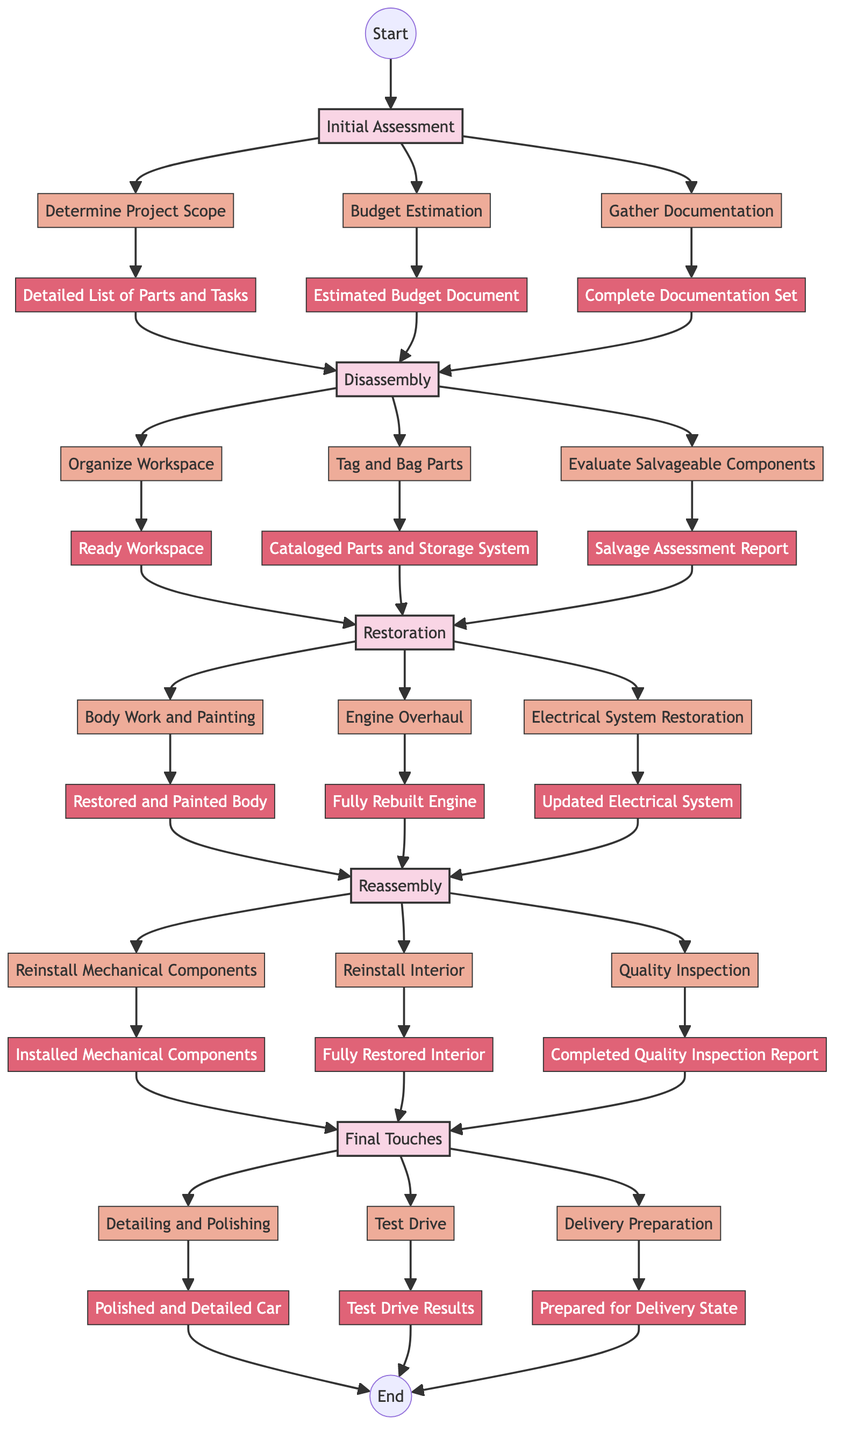What is the first phase in the restoration process? The diagram indicates that the first phase is labeled "Initial Assessment." This is the starting point of the flowchart, leading to steps involved in assessing the vintage car.
Answer: Initial Assessment How many steps are in the "Disassembly" phase? The "Disassembly" phase comprises three steps as indicated by the connections in the flowchart leading from the phase to each step node.
Answer: 3 What document is produced after "Budget Estimation"? According to the flowchart, after the "Budget Estimation" step, the output is labeled "Estimated Budget Document," indicating that it is the resulting documentation from that step.
Answer: Estimated Budget Document What must be done after "Organize Workspace"? Following the "Organize Workspace" step in the "Disassembly" phase, the next logical step is "Tag and Bag Parts," demonstrating the sequence of tasks in the restoration process.
Answer: Tag and Bag Parts In which phase do we perform the "Test Drive"? The "Test Drive" occurs in the "Final Touches" phase, as shown by the structure of the flowchart leading through the steps to the outputs associated with that final phase.
Answer: Final Touches How many total phases are represented in this diagram? The diagram outlines five distinct phases in the restoration process. By counting the linked phase nodes, the total is confirmed.
Answer: 5 What is the final output of the restoration process? The final output labeled in the diagram is "Prepared for Delivery State," which signifies the completion of all prior steps leading to the end of the restoration project.
Answer: Prepared for Delivery State Which step follows "Electrical System Restoration"? The flowchart indicates that the step following "Electrical System Restoration" is "Reinstall Mechanical Components," establishing the progression from restoration to reassembly.
Answer: Reinstall Mechanical Components What purpose does "Gather Documentation" serve in the process? The "Gather Documentation" step identifies its function in compiling essential records related to the vintage car, which is crucial for planning the restoration accurately.
Answer: Complete Documentation Set 